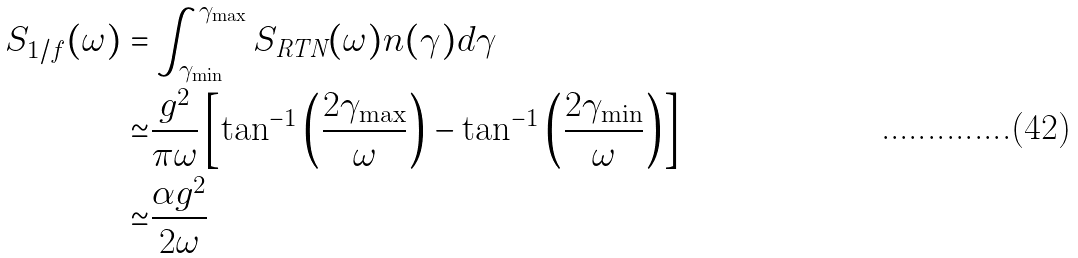Convert formula to latex. <formula><loc_0><loc_0><loc_500><loc_500>S _ { 1 / f } ( \omega ) = & \int _ { \gamma _ { \min } } ^ { \gamma _ { \max } } S _ { \text {RTN} } ( \omega ) n ( \gamma ) d \gamma \\ \simeq & \frac { g ^ { 2 } } { \pi \omega } \left [ \tan ^ { - 1 } \left ( \frac { 2 \gamma _ { \max } } { \omega } \right ) - \tan ^ { - 1 } \left ( \frac { 2 \gamma _ { \min } } { \omega } \right ) \right ] \\ \simeq & \frac { \alpha g ^ { 2 } } { 2 \omega }</formula> 